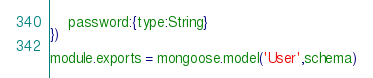Convert code to text. <code><loc_0><loc_0><loc_500><loc_500><_JavaScript_>    password:{type:String}
})

module.exports = mongoose.model('User',schema)</code> 